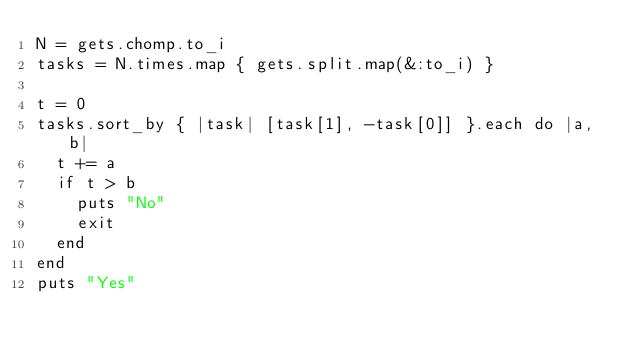Convert code to text. <code><loc_0><loc_0><loc_500><loc_500><_Ruby_>N = gets.chomp.to_i
tasks = N.times.map { gets.split.map(&:to_i) }

t = 0
tasks.sort_by { |task| [task[1], -task[0]] }.each do |a, b|
  t += a
  if t > b
    puts "No"
    exit
  end
end
puts "Yes"
</code> 